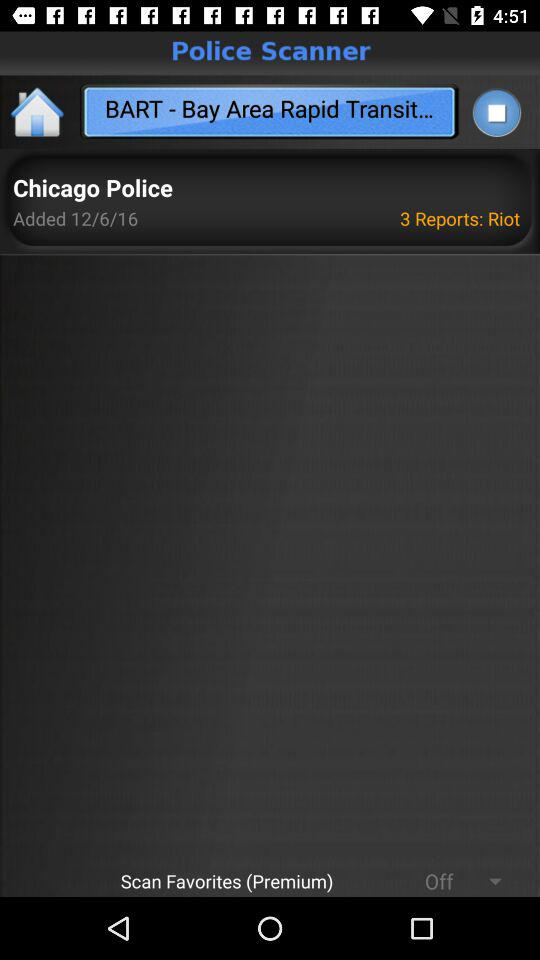How many reports were added? There were 3 reports added. 